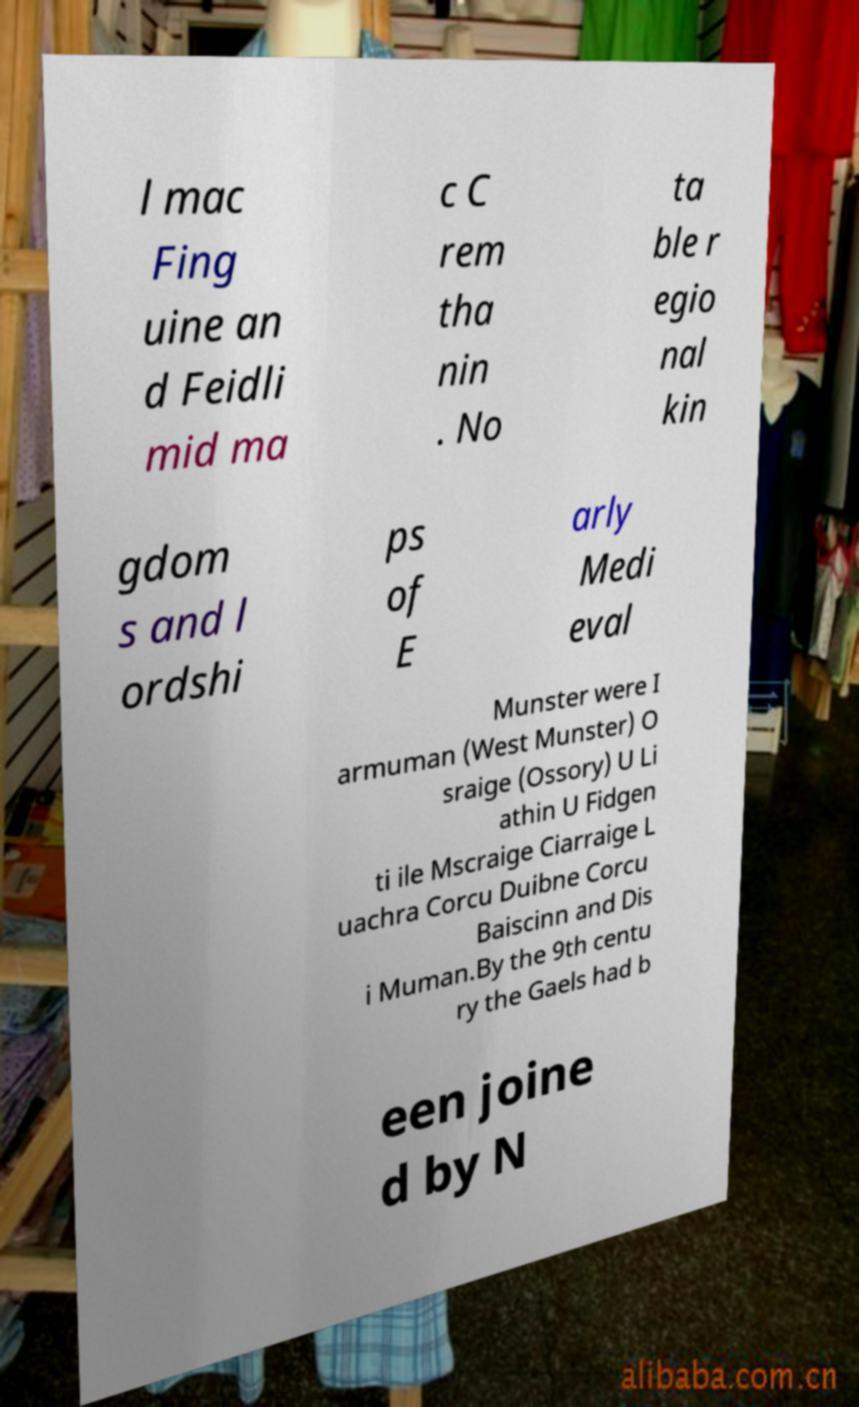For documentation purposes, I need the text within this image transcribed. Could you provide that? l mac Fing uine an d Feidli mid ma c C rem tha nin . No ta ble r egio nal kin gdom s and l ordshi ps of E arly Medi eval Munster were I armuman (West Munster) O sraige (Ossory) U Li athin U Fidgen ti ile Mscraige Ciarraige L uachra Corcu Duibne Corcu Baiscinn and Dis i Muman.By the 9th centu ry the Gaels had b een joine d by N 